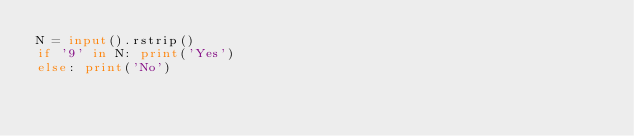<code> <loc_0><loc_0><loc_500><loc_500><_Python_>N = input().rstrip()
if '9' in N: print('Yes')
else: print('No')</code> 